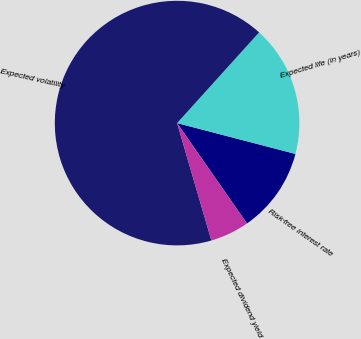Convert chart. <chart><loc_0><loc_0><loc_500><loc_500><pie_chart><fcel>Risk-free interest rate<fcel>Expected life (in years)<fcel>Expected volatility<fcel>Expected dividend yield<nl><fcel>11.26%<fcel>17.36%<fcel>66.22%<fcel>5.16%<nl></chart> 